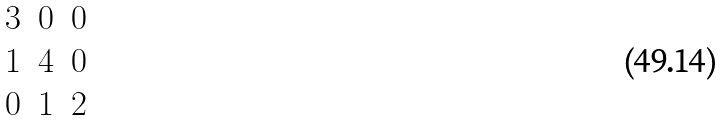<formula> <loc_0><loc_0><loc_500><loc_500>\begin{matrix} 3 & 0 & 0 \\ 1 & 4 & 0 \\ 0 & 1 & 2 \end{matrix}</formula> 